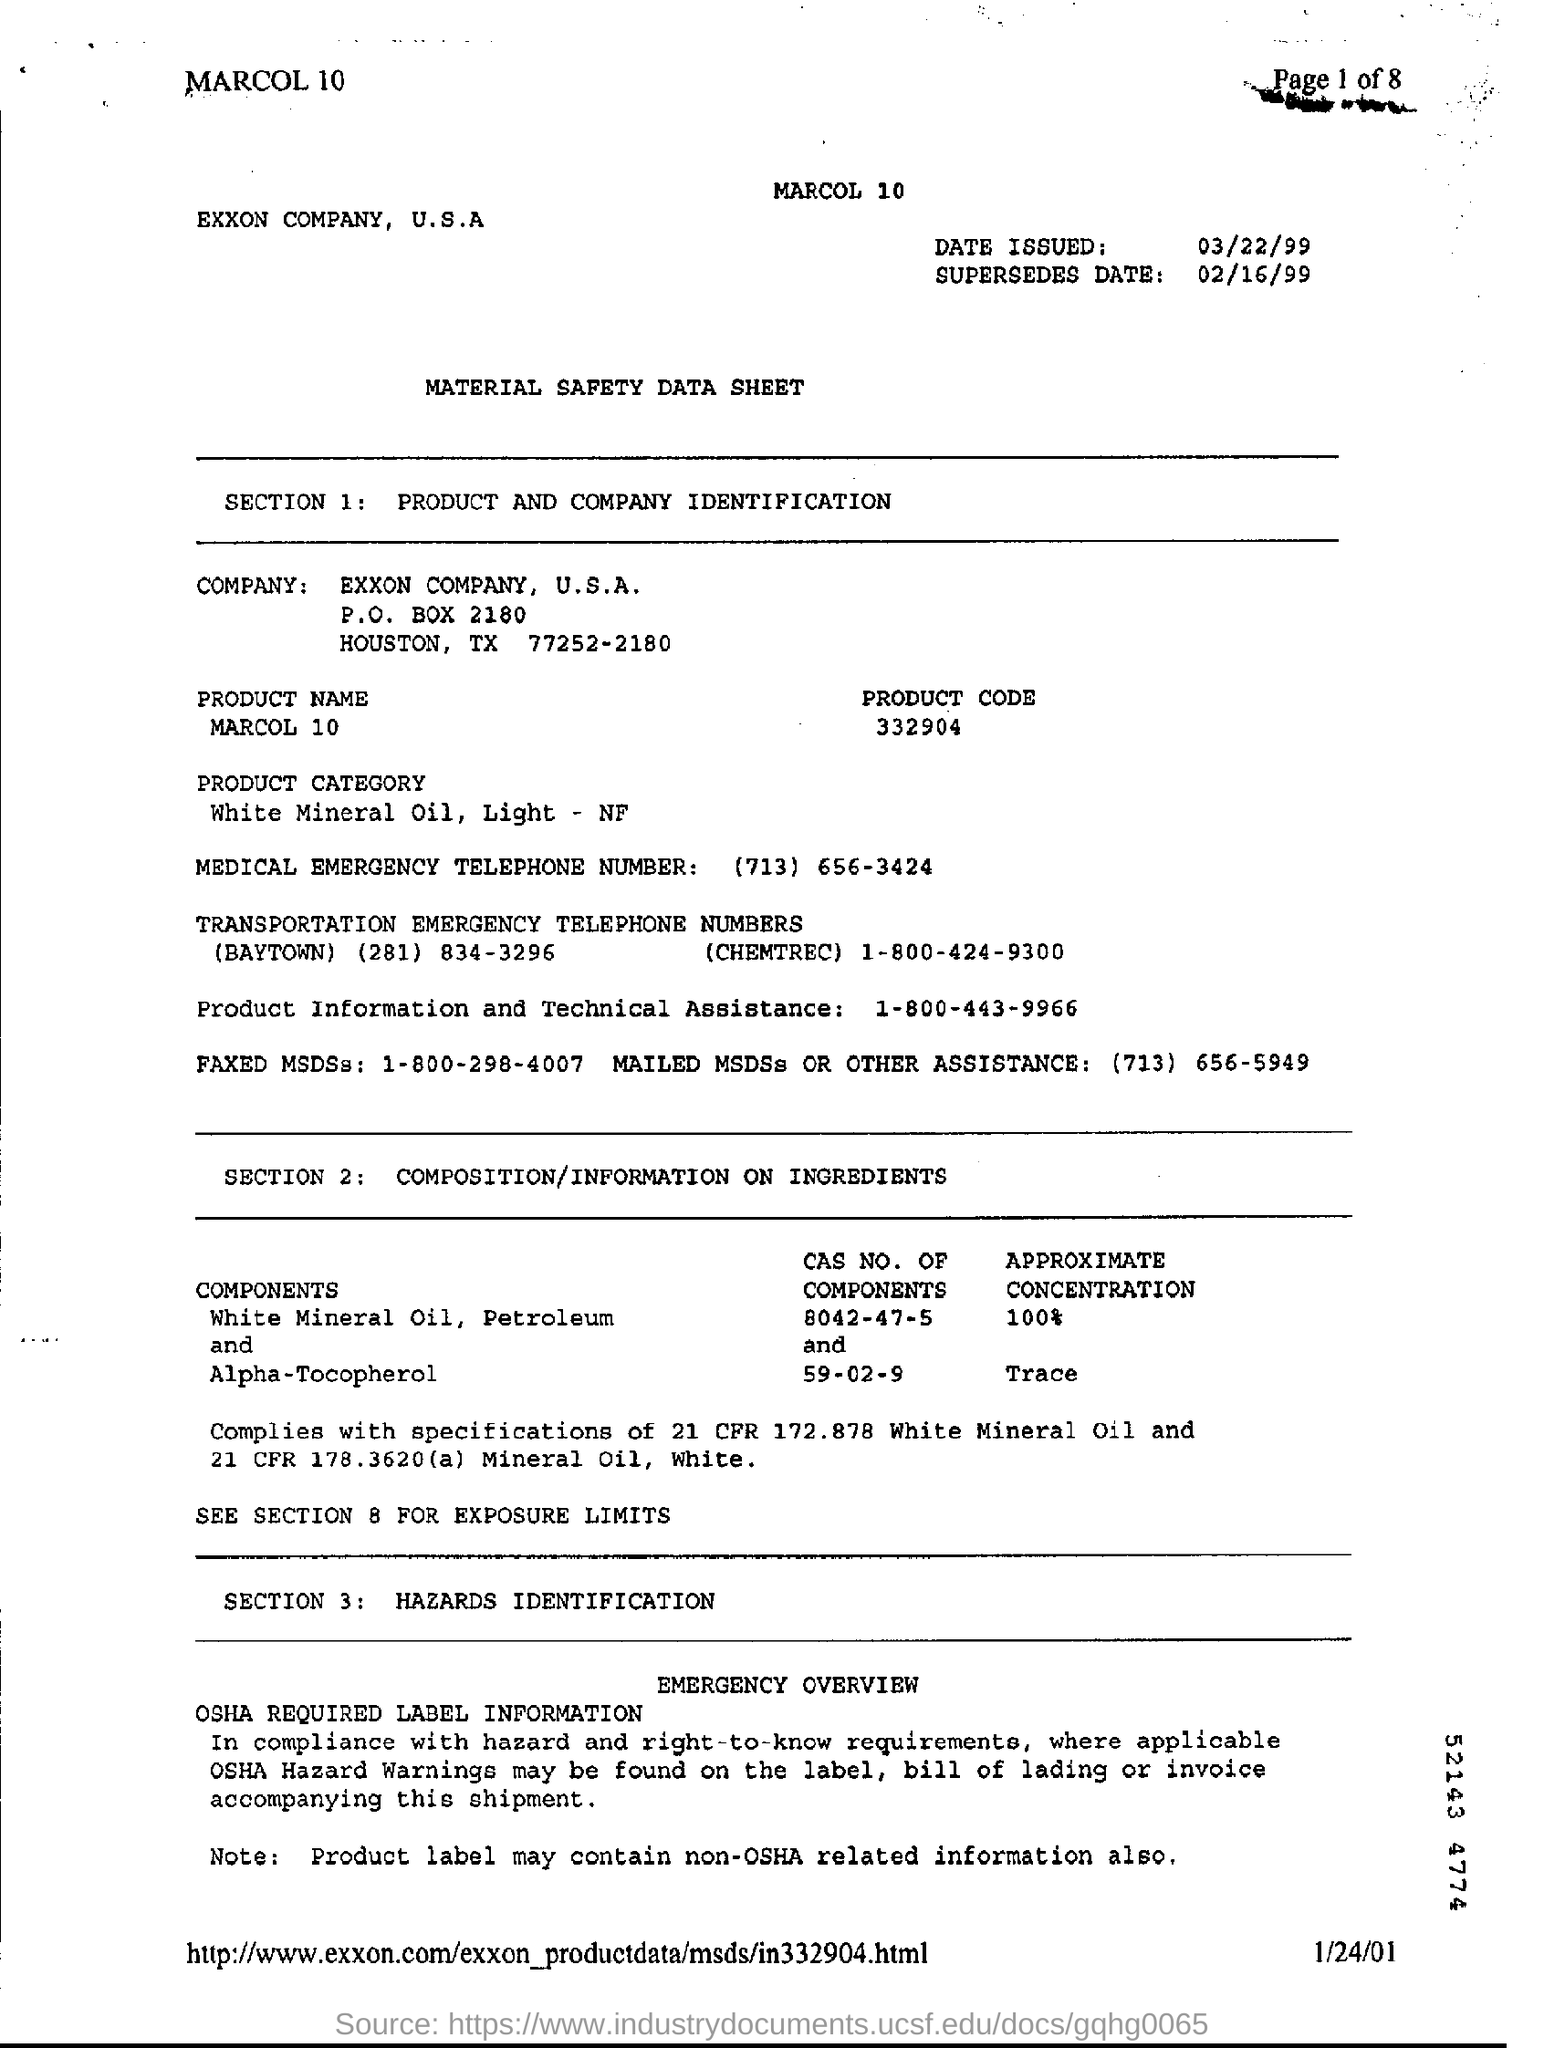List a handful of essential elements in this visual. The product name is MARCOL 10. The supersedes date is February 16, 1999. The date issued is March 22, 1999. This product is a category of mineral oil known as white mineral oil, light, which is a National Formulary (NF) grade. The product code is 332904... 